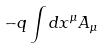Convert formula to latex. <formula><loc_0><loc_0><loc_500><loc_500>- q \int d x ^ { \mu } A _ { \mu }</formula> 